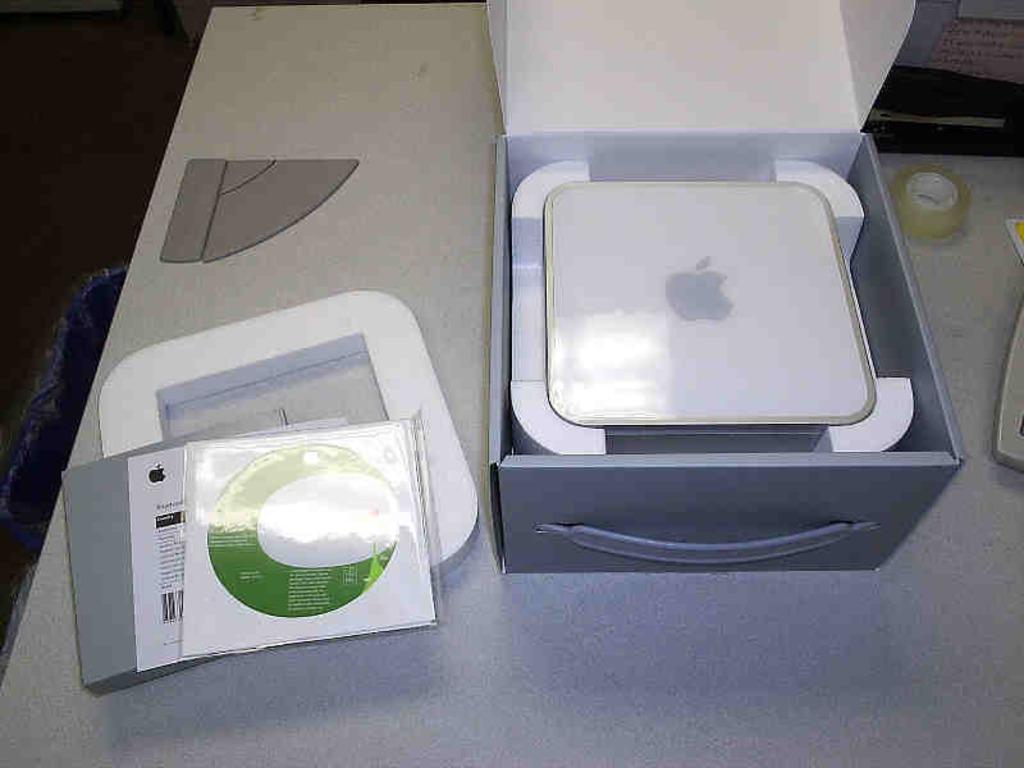Could you give a brief overview of what you see in this image? In the center of the image we can see books, paper and box placed on the table. 